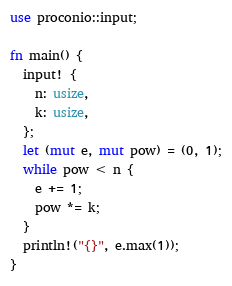<code> <loc_0><loc_0><loc_500><loc_500><_Rust_>use proconio::input;

fn main() {
  input! {
    n: usize,
    k: usize,
  };
  let (mut e, mut pow) = (0, 1);
  while pow < n {
    e += 1;
    pow *= k;
  }
  println!("{}", e.max(1));
}
</code> 